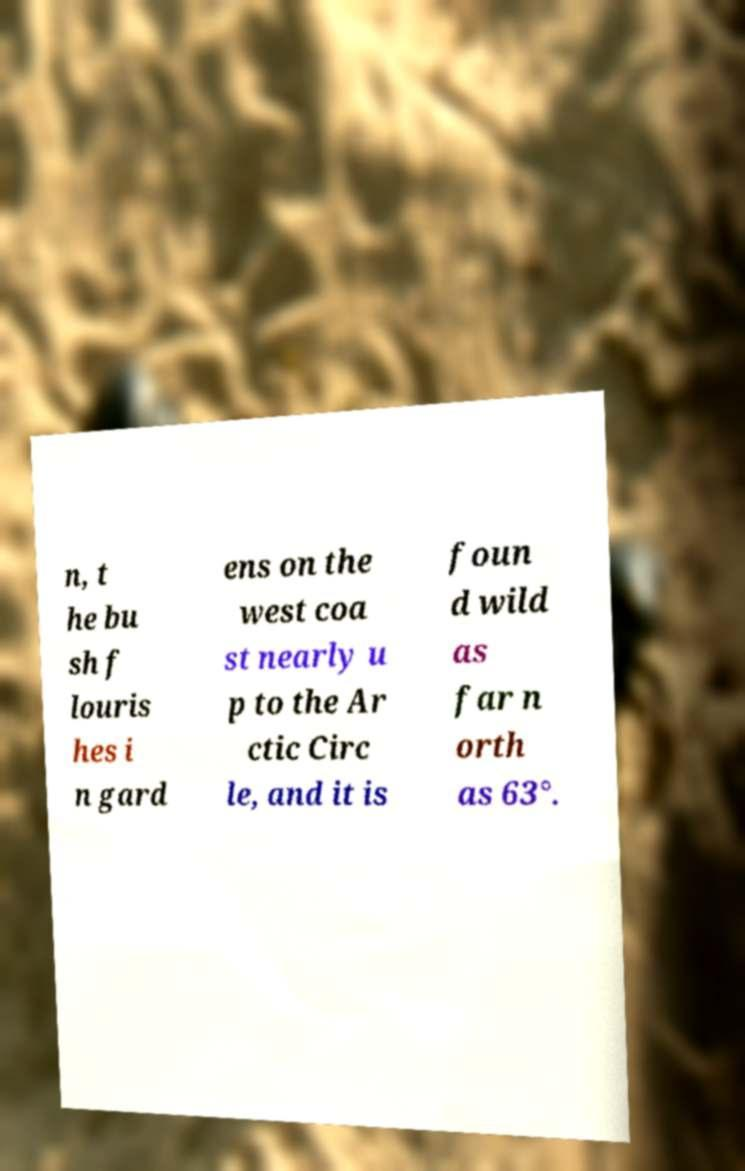What messages or text are displayed in this image? I need them in a readable, typed format. n, t he bu sh f louris hes i n gard ens on the west coa st nearly u p to the Ar ctic Circ le, and it is foun d wild as far n orth as 63°. 